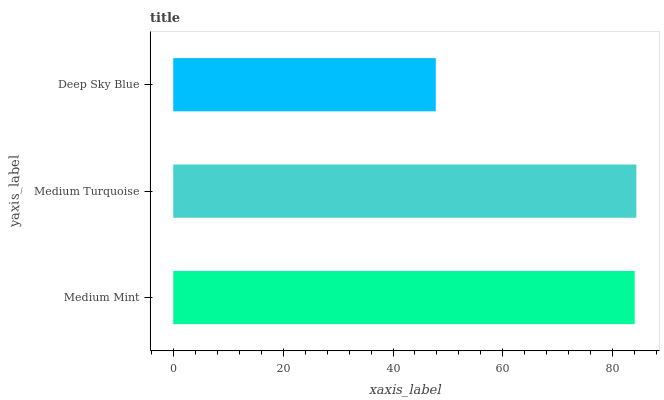Is Deep Sky Blue the minimum?
Answer yes or no. Yes. Is Medium Turquoise the maximum?
Answer yes or no. Yes. Is Medium Turquoise the minimum?
Answer yes or no. No. Is Deep Sky Blue the maximum?
Answer yes or no. No. Is Medium Turquoise greater than Deep Sky Blue?
Answer yes or no. Yes. Is Deep Sky Blue less than Medium Turquoise?
Answer yes or no. Yes. Is Deep Sky Blue greater than Medium Turquoise?
Answer yes or no. No. Is Medium Turquoise less than Deep Sky Blue?
Answer yes or no. No. Is Medium Mint the high median?
Answer yes or no. Yes. Is Medium Mint the low median?
Answer yes or no. Yes. Is Deep Sky Blue the high median?
Answer yes or no. No. Is Medium Turquoise the low median?
Answer yes or no. No. 